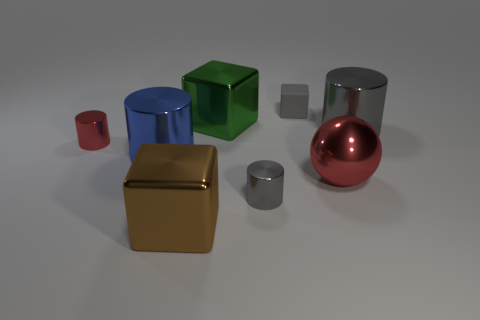What is the big brown thing on the left side of the gray object in front of the large gray cylinder made of?
Make the answer very short. Metal. Is the big gray thing made of the same material as the large cylinder in front of the small red cylinder?
Offer a very short reply. Yes. How many things are tiny cylinders on the left side of the large green cube or metal blocks?
Provide a short and direct response. 3. Are there any big shiny cubes of the same color as the big metal sphere?
Your answer should be very brief. No. There is a large green metallic thing; is its shape the same as the large metallic thing that is in front of the red ball?
Offer a very short reply. Yes. What number of objects are in front of the small rubber block and left of the large red thing?
Offer a terse response. 5. There is a gray thing that is the same shape as the green metal object; what material is it?
Provide a succinct answer. Rubber. What size is the gray metal thing in front of the red object to the left of the brown metal cube?
Provide a succinct answer. Small. Is there a green shiny cylinder?
Your answer should be compact. No. What material is the gray object that is both left of the big red metal sphere and to the right of the small gray metallic object?
Offer a terse response. Rubber. 